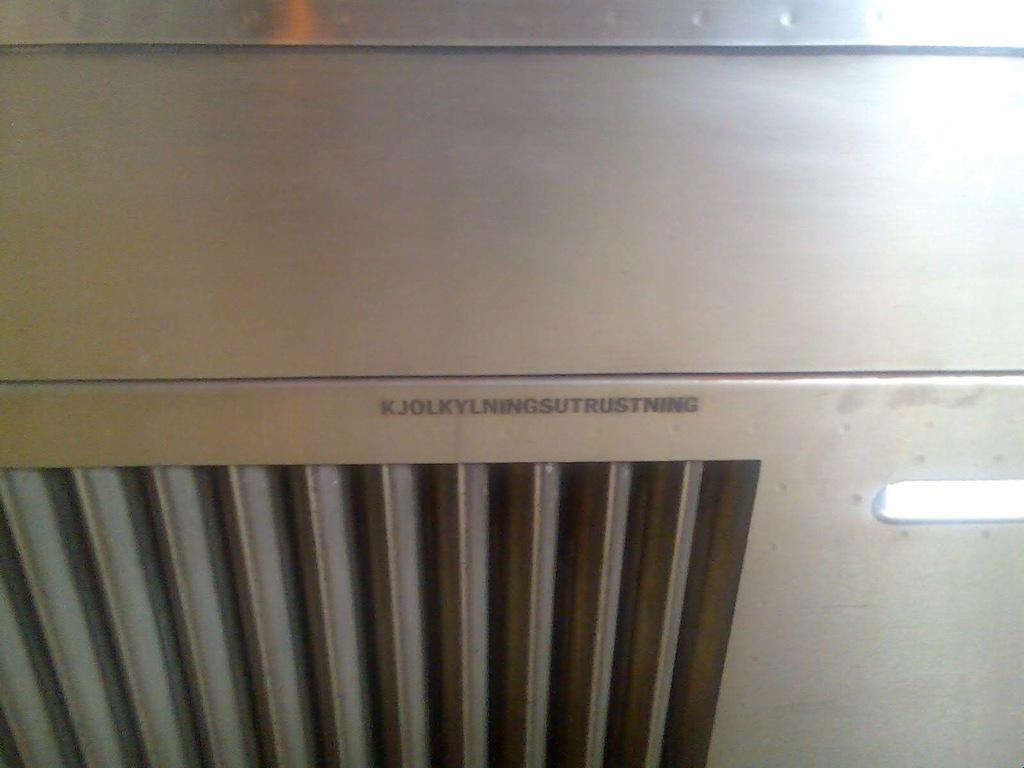<image>
Relay a brief, clear account of the picture shown. KJOLKYLNINGSUTRUSTNING reads the model number on the front of this machine. 